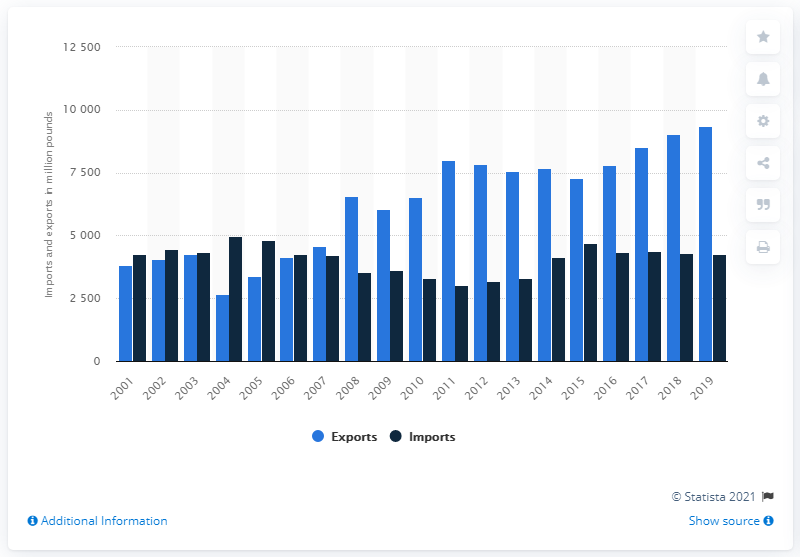Highlight a few significant elements in this photo. In 2019, a total of 9,032 metric tons of red meat was exported to the United States. 